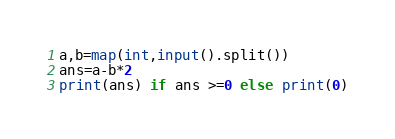Convert code to text. <code><loc_0><loc_0><loc_500><loc_500><_Python_>a,b=map(int,input().split())
ans=a-b*2
print(ans) if ans >=0 else print(0)</code> 